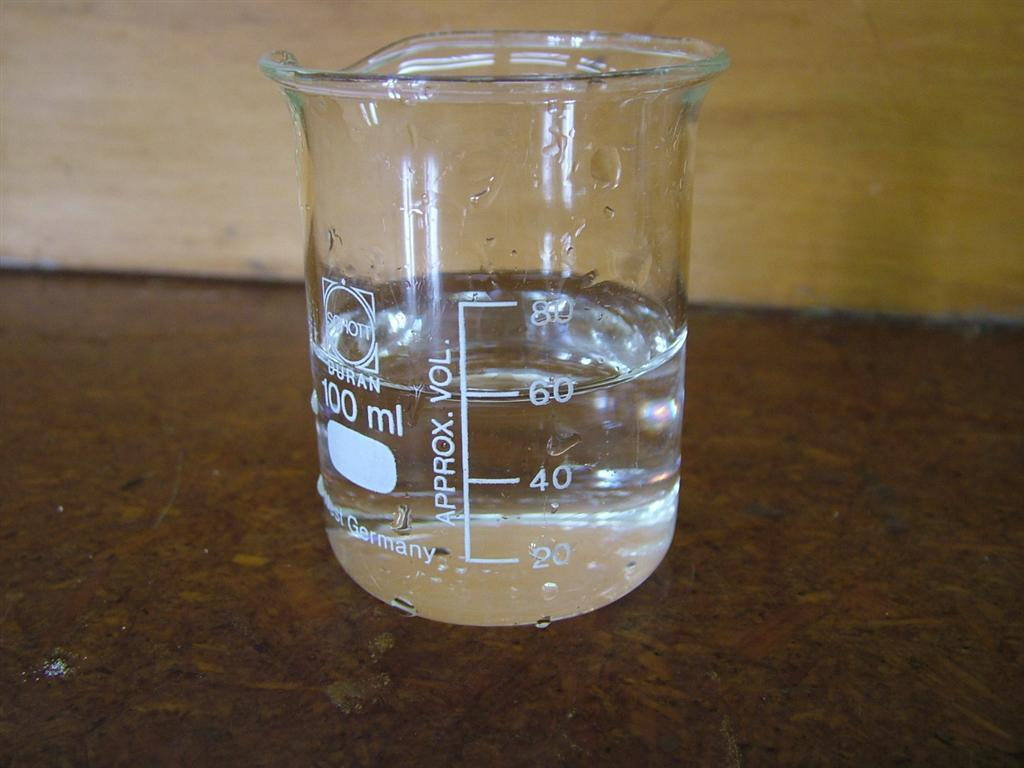<image>
Summarize the visual content of the image. a measuring cup filled with clear liquid with APPROX. VOL. at 60 with Germany written on it too. 